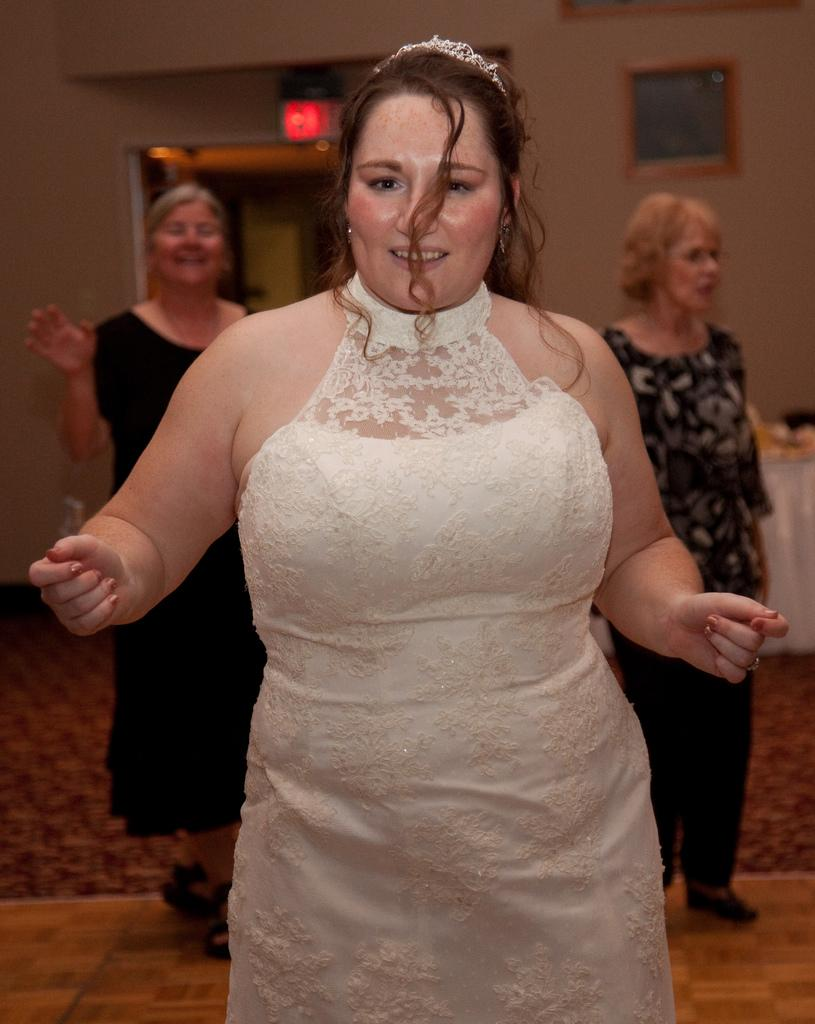How many women are present in the image? There are three women in the image. What are the women doing in the image? Two of the women are standing on the floor, and all three women are smiling. Can you describe any specific accessory in the image? Yes, there is a crown in the image. What is on the wall in the image? There is a frame on the wall. What type of lighting is present in the image? There is a light in the image. What can be seen in the background of the image? There are objects visible in the background. Can you tell me how many trees are visible in the image? There are no trees visible in the image; the focus is on the three women and the objects around them. 